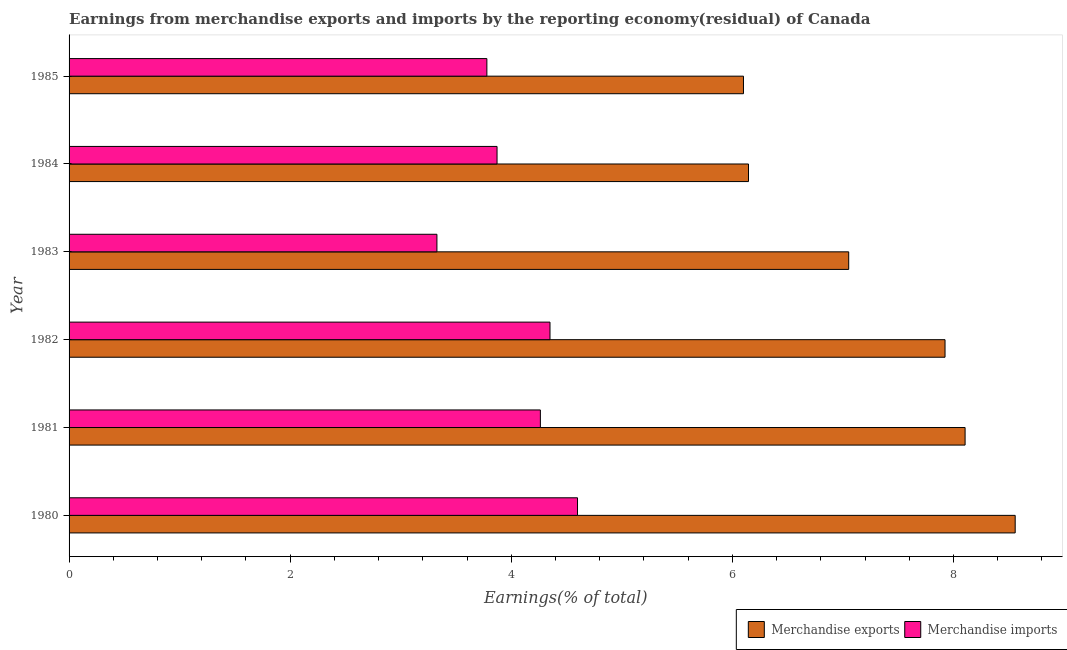How many different coloured bars are there?
Offer a terse response. 2. How many groups of bars are there?
Your response must be concise. 6. Are the number of bars on each tick of the Y-axis equal?
Offer a terse response. Yes. In how many cases, is the number of bars for a given year not equal to the number of legend labels?
Provide a succinct answer. 0. What is the earnings from merchandise exports in 1985?
Provide a short and direct response. 6.1. Across all years, what is the maximum earnings from merchandise exports?
Make the answer very short. 8.56. Across all years, what is the minimum earnings from merchandise imports?
Keep it short and to the point. 3.33. What is the total earnings from merchandise imports in the graph?
Your answer should be very brief. 24.19. What is the difference between the earnings from merchandise exports in 1981 and that in 1982?
Ensure brevity in your answer.  0.18. What is the difference between the earnings from merchandise exports in 1981 and the earnings from merchandise imports in 1982?
Provide a succinct answer. 3.75. What is the average earnings from merchandise imports per year?
Your response must be concise. 4.03. In the year 1983, what is the difference between the earnings from merchandise exports and earnings from merchandise imports?
Offer a terse response. 3.73. In how many years, is the earnings from merchandise exports greater than 8.4 %?
Offer a very short reply. 1. What is the ratio of the earnings from merchandise exports in 1980 to that in 1983?
Your answer should be very brief. 1.21. Is the earnings from merchandise exports in 1980 less than that in 1985?
Provide a succinct answer. No. Is the difference between the earnings from merchandise exports in 1980 and 1982 greater than the difference between the earnings from merchandise imports in 1980 and 1982?
Your answer should be compact. Yes. What is the difference between the highest and the second highest earnings from merchandise exports?
Your answer should be compact. 0.45. What is the difference between the highest and the lowest earnings from merchandise imports?
Keep it short and to the point. 1.27. In how many years, is the earnings from merchandise imports greater than the average earnings from merchandise imports taken over all years?
Your response must be concise. 3. Is the sum of the earnings from merchandise imports in 1982 and 1984 greater than the maximum earnings from merchandise exports across all years?
Your response must be concise. No. What does the 1st bar from the top in 1981 represents?
Offer a terse response. Merchandise imports. How many bars are there?
Offer a very short reply. 12. Are all the bars in the graph horizontal?
Provide a succinct answer. Yes. How many years are there in the graph?
Provide a short and direct response. 6. Does the graph contain grids?
Your response must be concise. No. How are the legend labels stacked?
Provide a succinct answer. Horizontal. What is the title of the graph?
Ensure brevity in your answer.  Earnings from merchandise exports and imports by the reporting economy(residual) of Canada. Does "Agricultural land" appear as one of the legend labels in the graph?
Offer a terse response. No. What is the label or title of the X-axis?
Ensure brevity in your answer.  Earnings(% of total). What is the label or title of the Y-axis?
Make the answer very short. Year. What is the Earnings(% of total) of Merchandise exports in 1980?
Offer a terse response. 8.56. What is the Earnings(% of total) in Merchandise imports in 1980?
Provide a short and direct response. 4.6. What is the Earnings(% of total) in Merchandise exports in 1981?
Keep it short and to the point. 8.11. What is the Earnings(% of total) of Merchandise imports in 1981?
Your response must be concise. 4.26. What is the Earnings(% of total) of Merchandise exports in 1982?
Provide a short and direct response. 7.92. What is the Earnings(% of total) of Merchandise imports in 1982?
Offer a very short reply. 4.35. What is the Earnings(% of total) in Merchandise exports in 1983?
Make the answer very short. 7.05. What is the Earnings(% of total) of Merchandise imports in 1983?
Give a very brief answer. 3.33. What is the Earnings(% of total) in Merchandise exports in 1984?
Your response must be concise. 6.15. What is the Earnings(% of total) in Merchandise imports in 1984?
Offer a terse response. 3.87. What is the Earnings(% of total) in Merchandise exports in 1985?
Your response must be concise. 6.1. What is the Earnings(% of total) in Merchandise imports in 1985?
Provide a short and direct response. 3.78. Across all years, what is the maximum Earnings(% of total) in Merchandise exports?
Your answer should be very brief. 8.56. Across all years, what is the maximum Earnings(% of total) of Merchandise imports?
Make the answer very short. 4.6. Across all years, what is the minimum Earnings(% of total) of Merchandise exports?
Your answer should be very brief. 6.1. Across all years, what is the minimum Earnings(% of total) in Merchandise imports?
Your response must be concise. 3.33. What is the total Earnings(% of total) of Merchandise exports in the graph?
Ensure brevity in your answer.  43.89. What is the total Earnings(% of total) in Merchandise imports in the graph?
Offer a terse response. 24.19. What is the difference between the Earnings(% of total) in Merchandise exports in 1980 and that in 1981?
Ensure brevity in your answer.  0.45. What is the difference between the Earnings(% of total) in Merchandise imports in 1980 and that in 1981?
Make the answer very short. 0.34. What is the difference between the Earnings(% of total) in Merchandise exports in 1980 and that in 1982?
Offer a very short reply. 0.63. What is the difference between the Earnings(% of total) of Merchandise imports in 1980 and that in 1982?
Provide a short and direct response. 0.25. What is the difference between the Earnings(% of total) in Merchandise exports in 1980 and that in 1983?
Provide a short and direct response. 1.51. What is the difference between the Earnings(% of total) in Merchandise imports in 1980 and that in 1983?
Keep it short and to the point. 1.27. What is the difference between the Earnings(% of total) of Merchandise exports in 1980 and that in 1984?
Provide a short and direct response. 2.41. What is the difference between the Earnings(% of total) of Merchandise imports in 1980 and that in 1984?
Ensure brevity in your answer.  0.73. What is the difference between the Earnings(% of total) in Merchandise exports in 1980 and that in 1985?
Provide a succinct answer. 2.46. What is the difference between the Earnings(% of total) of Merchandise imports in 1980 and that in 1985?
Your response must be concise. 0.82. What is the difference between the Earnings(% of total) of Merchandise exports in 1981 and that in 1982?
Offer a very short reply. 0.18. What is the difference between the Earnings(% of total) in Merchandise imports in 1981 and that in 1982?
Keep it short and to the point. -0.09. What is the difference between the Earnings(% of total) of Merchandise exports in 1981 and that in 1983?
Offer a very short reply. 1.05. What is the difference between the Earnings(% of total) in Merchandise imports in 1981 and that in 1983?
Make the answer very short. 0.94. What is the difference between the Earnings(% of total) in Merchandise exports in 1981 and that in 1984?
Give a very brief answer. 1.96. What is the difference between the Earnings(% of total) in Merchandise imports in 1981 and that in 1984?
Your answer should be very brief. 0.39. What is the difference between the Earnings(% of total) in Merchandise exports in 1981 and that in 1985?
Your answer should be very brief. 2. What is the difference between the Earnings(% of total) in Merchandise imports in 1981 and that in 1985?
Make the answer very short. 0.48. What is the difference between the Earnings(% of total) in Merchandise exports in 1982 and that in 1983?
Provide a succinct answer. 0.87. What is the difference between the Earnings(% of total) of Merchandise imports in 1982 and that in 1983?
Make the answer very short. 1.02. What is the difference between the Earnings(% of total) in Merchandise exports in 1982 and that in 1984?
Offer a very short reply. 1.78. What is the difference between the Earnings(% of total) in Merchandise imports in 1982 and that in 1984?
Give a very brief answer. 0.48. What is the difference between the Earnings(% of total) in Merchandise exports in 1982 and that in 1985?
Offer a terse response. 1.82. What is the difference between the Earnings(% of total) in Merchandise imports in 1982 and that in 1985?
Your answer should be very brief. 0.57. What is the difference between the Earnings(% of total) in Merchandise exports in 1983 and that in 1984?
Provide a short and direct response. 0.91. What is the difference between the Earnings(% of total) of Merchandise imports in 1983 and that in 1984?
Offer a terse response. -0.54. What is the difference between the Earnings(% of total) in Merchandise exports in 1983 and that in 1985?
Make the answer very short. 0.95. What is the difference between the Earnings(% of total) of Merchandise imports in 1983 and that in 1985?
Ensure brevity in your answer.  -0.45. What is the difference between the Earnings(% of total) of Merchandise exports in 1984 and that in 1985?
Ensure brevity in your answer.  0.05. What is the difference between the Earnings(% of total) of Merchandise imports in 1984 and that in 1985?
Keep it short and to the point. 0.09. What is the difference between the Earnings(% of total) of Merchandise exports in 1980 and the Earnings(% of total) of Merchandise imports in 1981?
Make the answer very short. 4.3. What is the difference between the Earnings(% of total) of Merchandise exports in 1980 and the Earnings(% of total) of Merchandise imports in 1982?
Your answer should be very brief. 4.21. What is the difference between the Earnings(% of total) in Merchandise exports in 1980 and the Earnings(% of total) in Merchandise imports in 1983?
Your answer should be compact. 5.23. What is the difference between the Earnings(% of total) of Merchandise exports in 1980 and the Earnings(% of total) of Merchandise imports in 1984?
Make the answer very short. 4.69. What is the difference between the Earnings(% of total) of Merchandise exports in 1980 and the Earnings(% of total) of Merchandise imports in 1985?
Make the answer very short. 4.78. What is the difference between the Earnings(% of total) of Merchandise exports in 1981 and the Earnings(% of total) of Merchandise imports in 1982?
Keep it short and to the point. 3.75. What is the difference between the Earnings(% of total) of Merchandise exports in 1981 and the Earnings(% of total) of Merchandise imports in 1983?
Your answer should be compact. 4.78. What is the difference between the Earnings(% of total) in Merchandise exports in 1981 and the Earnings(% of total) in Merchandise imports in 1984?
Give a very brief answer. 4.23. What is the difference between the Earnings(% of total) of Merchandise exports in 1981 and the Earnings(% of total) of Merchandise imports in 1985?
Make the answer very short. 4.33. What is the difference between the Earnings(% of total) in Merchandise exports in 1982 and the Earnings(% of total) in Merchandise imports in 1983?
Your answer should be compact. 4.6. What is the difference between the Earnings(% of total) of Merchandise exports in 1982 and the Earnings(% of total) of Merchandise imports in 1984?
Ensure brevity in your answer.  4.05. What is the difference between the Earnings(% of total) in Merchandise exports in 1982 and the Earnings(% of total) in Merchandise imports in 1985?
Your response must be concise. 4.14. What is the difference between the Earnings(% of total) of Merchandise exports in 1983 and the Earnings(% of total) of Merchandise imports in 1984?
Your response must be concise. 3.18. What is the difference between the Earnings(% of total) of Merchandise exports in 1983 and the Earnings(% of total) of Merchandise imports in 1985?
Keep it short and to the point. 3.27. What is the difference between the Earnings(% of total) in Merchandise exports in 1984 and the Earnings(% of total) in Merchandise imports in 1985?
Offer a very short reply. 2.37. What is the average Earnings(% of total) in Merchandise exports per year?
Your answer should be compact. 7.31. What is the average Earnings(% of total) of Merchandise imports per year?
Your answer should be compact. 4.03. In the year 1980, what is the difference between the Earnings(% of total) in Merchandise exports and Earnings(% of total) in Merchandise imports?
Your response must be concise. 3.96. In the year 1981, what is the difference between the Earnings(% of total) in Merchandise exports and Earnings(% of total) in Merchandise imports?
Your response must be concise. 3.84. In the year 1982, what is the difference between the Earnings(% of total) in Merchandise exports and Earnings(% of total) in Merchandise imports?
Offer a terse response. 3.57. In the year 1983, what is the difference between the Earnings(% of total) in Merchandise exports and Earnings(% of total) in Merchandise imports?
Your answer should be very brief. 3.73. In the year 1984, what is the difference between the Earnings(% of total) of Merchandise exports and Earnings(% of total) of Merchandise imports?
Your answer should be compact. 2.27. In the year 1985, what is the difference between the Earnings(% of total) in Merchandise exports and Earnings(% of total) in Merchandise imports?
Offer a very short reply. 2.32. What is the ratio of the Earnings(% of total) in Merchandise exports in 1980 to that in 1981?
Offer a terse response. 1.06. What is the ratio of the Earnings(% of total) in Merchandise imports in 1980 to that in 1981?
Give a very brief answer. 1.08. What is the ratio of the Earnings(% of total) in Merchandise exports in 1980 to that in 1982?
Your response must be concise. 1.08. What is the ratio of the Earnings(% of total) in Merchandise imports in 1980 to that in 1982?
Offer a very short reply. 1.06. What is the ratio of the Earnings(% of total) in Merchandise exports in 1980 to that in 1983?
Offer a terse response. 1.21. What is the ratio of the Earnings(% of total) in Merchandise imports in 1980 to that in 1983?
Your answer should be compact. 1.38. What is the ratio of the Earnings(% of total) of Merchandise exports in 1980 to that in 1984?
Keep it short and to the point. 1.39. What is the ratio of the Earnings(% of total) in Merchandise imports in 1980 to that in 1984?
Offer a terse response. 1.19. What is the ratio of the Earnings(% of total) of Merchandise exports in 1980 to that in 1985?
Offer a terse response. 1.4. What is the ratio of the Earnings(% of total) in Merchandise imports in 1980 to that in 1985?
Offer a very short reply. 1.22. What is the ratio of the Earnings(% of total) in Merchandise exports in 1981 to that in 1982?
Offer a very short reply. 1.02. What is the ratio of the Earnings(% of total) of Merchandise imports in 1981 to that in 1982?
Offer a terse response. 0.98. What is the ratio of the Earnings(% of total) of Merchandise exports in 1981 to that in 1983?
Keep it short and to the point. 1.15. What is the ratio of the Earnings(% of total) in Merchandise imports in 1981 to that in 1983?
Make the answer very short. 1.28. What is the ratio of the Earnings(% of total) in Merchandise exports in 1981 to that in 1984?
Your response must be concise. 1.32. What is the ratio of the Earnings(% of total) in Merchandise imports in 1981 to that in 1984?
Give a very brief answer. 1.1. What is the ratio of the Earnings(% of total) in Merchandise exports in 1981 to that in 1985?
Make the answer very short. 1.33. What is the ratio of the Earnings(% of total) of Merchandise imports in 1981 to that in 1985?
Keep it short and to the point. 1.13. What is the ratio of the Earnings(% of total) in Merchandise exports in 1982 to that in 1983?
Ensure brevity in your answer.  1.12. What is the ratio of the Earnings(% of total) in Merchandise imports in 1982 to that in 1983?
Give a very brief answer. 1.31. What is the ratio of the Earnings(% of total) in Merchandise exports in 1982 to that in 1984?
Offer a terse response. 1.29. What is the ratio of the Earnings(% of total) of Merchandise imports in 1982 to that in 1984?
Give a very brief answer. 1.12. What is the ratio of the Earnings(% of total) in Merchandise exports in 1982 to that in 1985?
Offer a terse response. 1.3. What is the ratio of the Earnings(% of total) in Merchandise imports in 1982 to that in 1985?
Give a very brief answer. 1.15. What is the ratio of the Earnings(% of total) of Merchandise exports in 1983 to that in 1984?
Provide a succinct answer. 1.15. What is the ratio of the Earnings(% of total) in Merchandise imports in 1983 to that in 1984?
Your answer should be very brief. 0.86. What is the ratio of the Earnings(% of total) of Merchandise exports in 1983 to that in 1985?
Ensure brevity in your answer.  1.16. What is the ratio of the Earnings(% of total) of Merchandise imports in 1983 to that in 1985?
Offer a very short reply. 0.88. What is the ratio of the Earnings(% of total) in Merchandise exports in 1984 to that in 1985?
Your answer should be compact. 1.01. What is the ratio of the Earnings(% of total) in Merchandise imports in 1984 to that in 1985?
Keep it short and to the point. 1.02. What is the difference between the highest and the second highest Earnings(% of total) in Merchandise exports?
Make the answer very short. 0.45. What is the difference between the highest and the second highest Earnings(% of total) in Merchandise imports?
Your response must be concise. 0.25. What is the difference between the highest and the lowest Earnings(% of total) in Merchandise exports?
Offer a terse response. 2.46. What is the difference between the highest and the lowest Earnings(% of total) in Merchandise imports?
Provide a short and direct response. 1.27. 